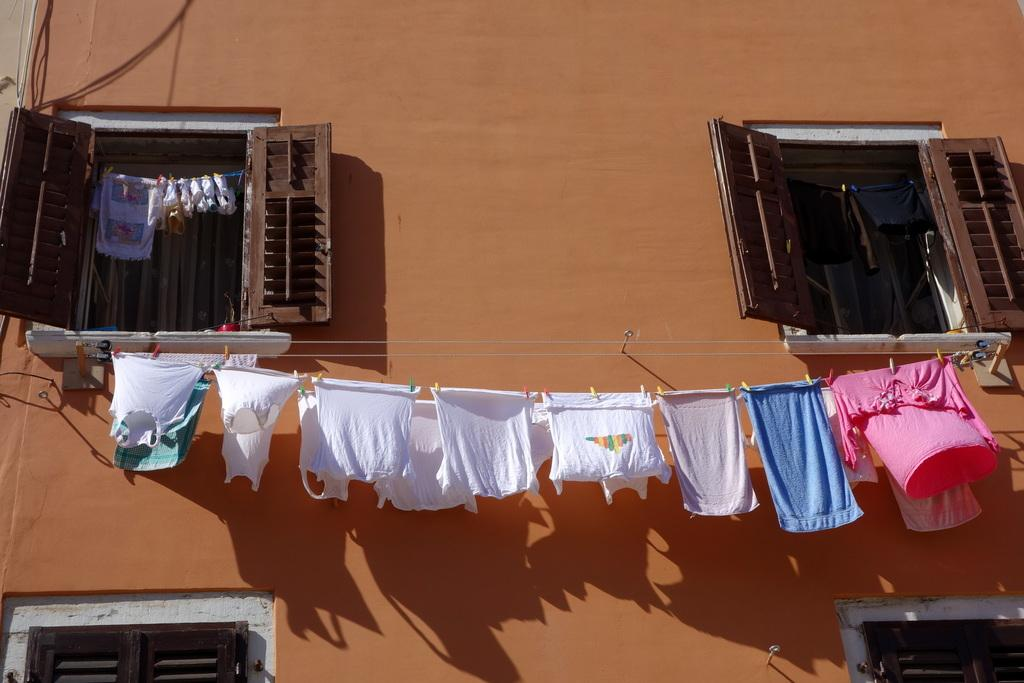What is being hung on the rope in the image? There are clothes hanging on a rope in the image. What is used to attach the clothes to the rope? Clips are visible in the image. What type of structure can be seen in the image? There is a wall in the image. What else is present in the image besides the clothes and wall? Cables and windows are present in the image. Where is the shoe placed on the tray in the image? There is no shoe or tray present in the image. What type of needle is being used to sew the clothes in the image? There is no needle visible in the image; the clothes are hanging on a rope using clips. 